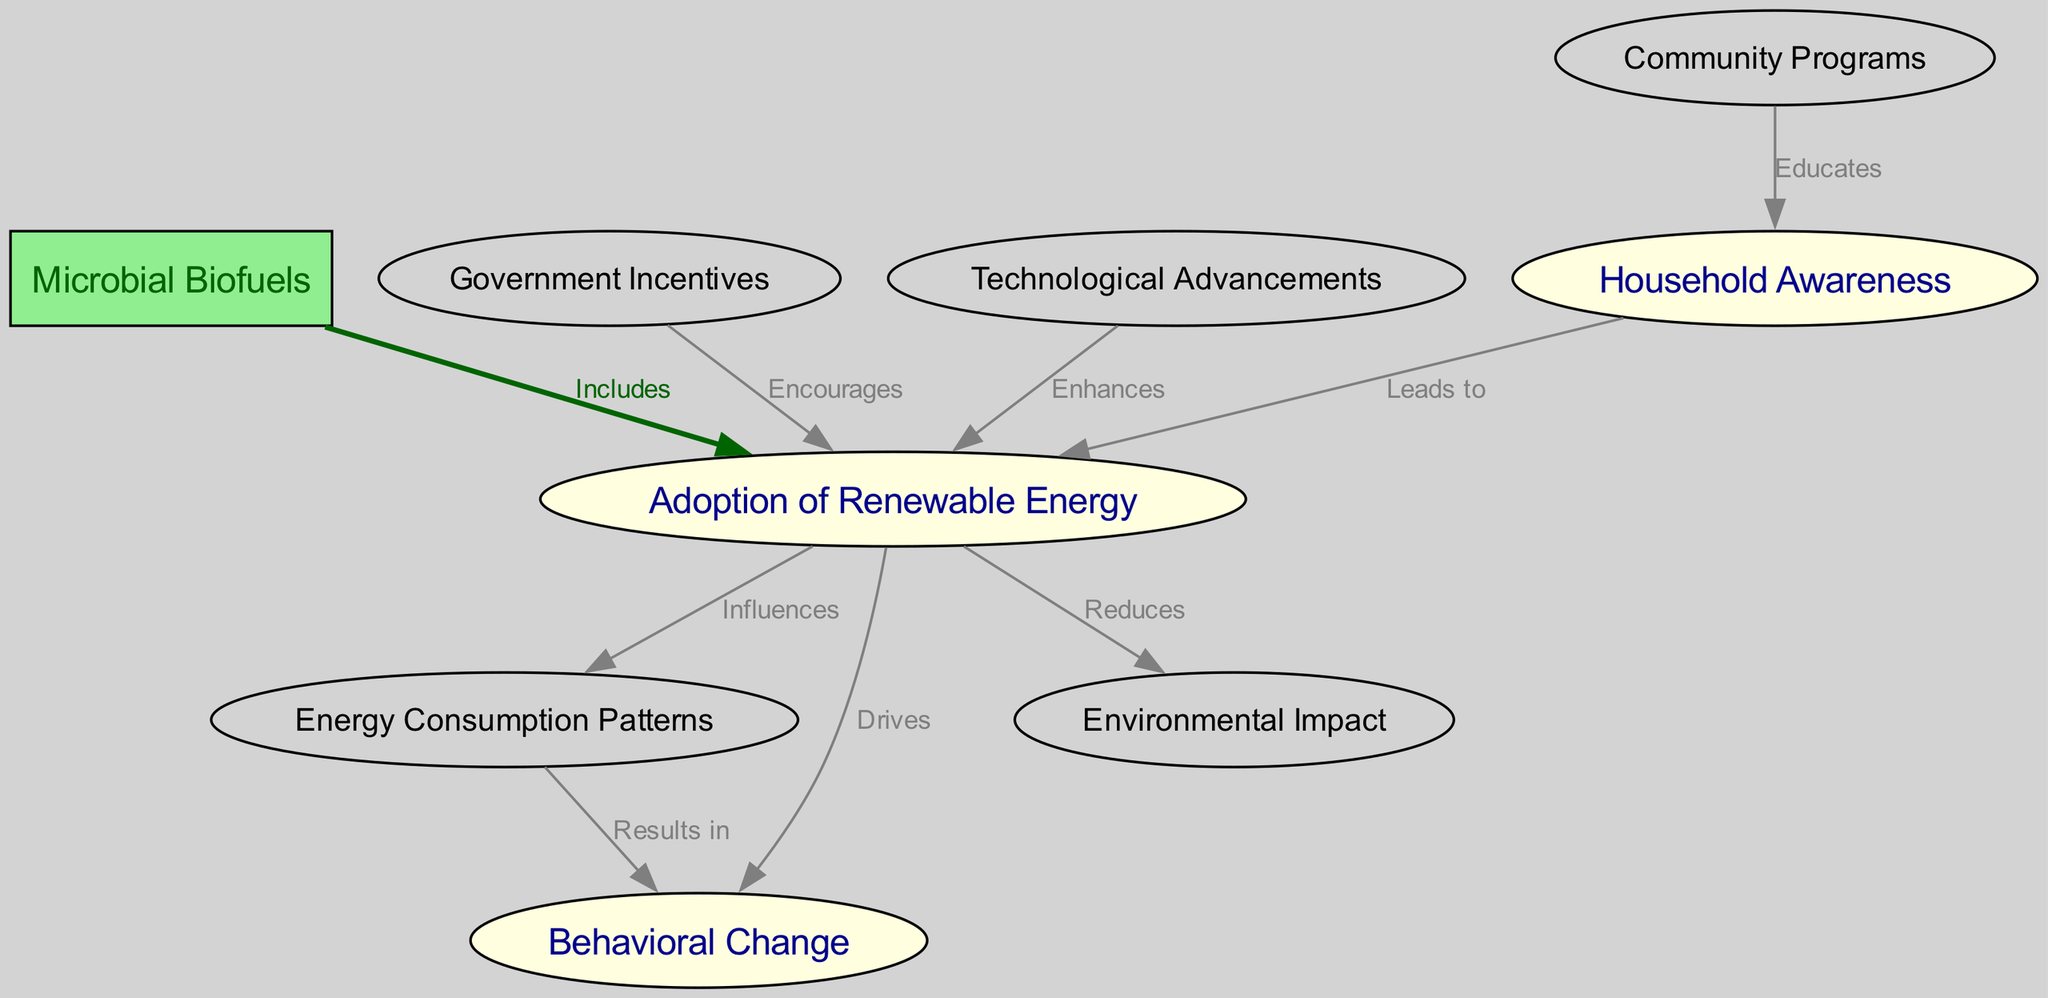What is the total number of nodes in the diagram? The diagram includes a list of nodes, which are: Household Awareness, Adoption of Renewable Energy, Energy Consumption Patterns, Microbial Biofuels, Behavioral Change, Government Incentives, Environmental Impact, Technological Advancements, and Community Programs. Counting these, there are a total of 9 nodes.
Answer: 9 Which node influences Energy Consumption Patterns? The edge in the diagram shows that the Adoption of Renewable Energy directly influences Energy Consumption Patterns, as indicated by the labeled connection between these two nodes.
Answer: Adoption of Renewable Energy What do Government Incentives encourage? The diagram indicates that Government Incentives encourage the Adoption of Renewable Energy, which is shown through the directed edge connecting these two nodes with the label "Encourages".
Answer: Adoption of Renewable Energy What is the relationship between Behavioral Change and Energy Consumption Patterns? The diagram shows a direct connection from Energy Consumption Patterns to Behavioral Change, labeled "Results in", indicating that changes in energy consumption patterns will result in behavioral changes.
Answer: Results in Which node is highlighted as being connected to Microbial Biofuels? The diagram specifically highlights the connection to Microbial Biofuels for the node Adoption of Renewable Energy, as it shows that Microbial Biofuels include this adoption as part of its context.
Answer: Adoption of Renewable Energy What is the main effect of adopting renewable energy according to the diagram? The diagram illustrates that adopting renewable energy drives Behavioral Change, as indicated by the direct connection between these two nodes with the label "Drives".
Answer: Drives Behavioral Change How does Community Programs contribute to Household Awareness? The diagram illustrates that Community Programs educate households, which is shown through the directed edge that connects Community Programs to Household Awareness with the label "Educates".
Answer: Educates Which node reduces Environmental Impact? The diagram states that adopting renewable energy reduces Environmental Impact, as shown by the connecting edge labeled "Reduces" that originates from the Adoption of Renewable Energy towards the Environmental Impact node.
Answer: Reduces What type of advancements enhance the adoption of renewable energy? The diagram shows that Technological Advancements enhance the Adoption of Renewable Energy, highlighted by the directed edge that connects these two nodes with the label "Enhances".
Answer: Enhances 